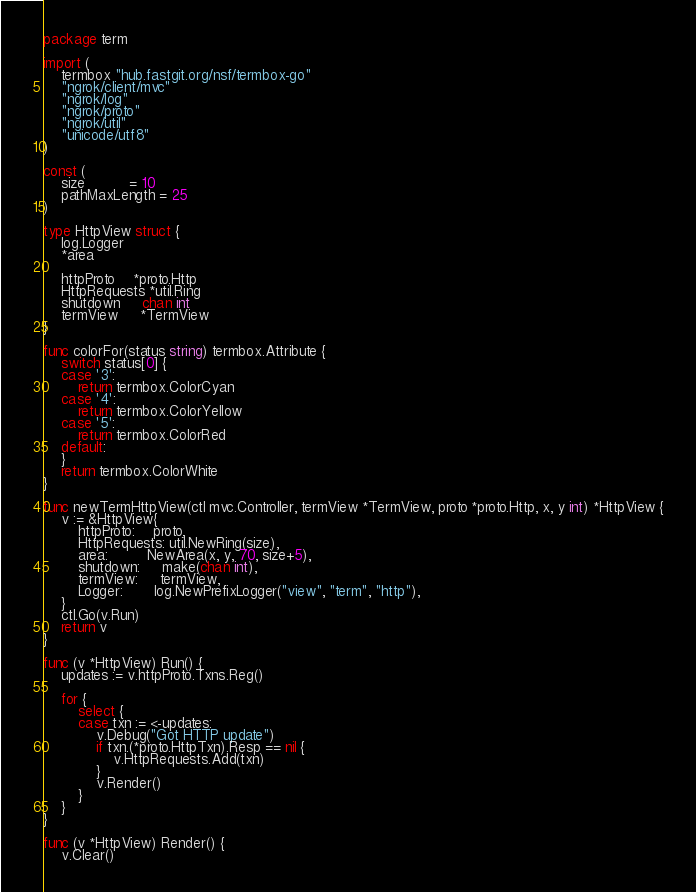Convert code to text. <code><loc_0><loc_0><loc_500><loc_500><_Go_>package term

import (
	termbox "hub.fastgit.org/nsf/termbox-go"
	"ngrok/client/mvc"
	"ngrok/log"
	"ngrok/proto"
	"ngrok/util"
	"unicode/utf8"
)

const (
	size          = 10
	pathMaxLength = 25
)

type HttpView struct {
	log.Logger
	*area

	httpProto    *proto.Http
	HttpRequests *util.Ring
	shutdown     chan int
	termView     *TermView
}

func colorFor(status string) termbox.Attribute {
	switch status[0] {
	case '3':
		return termbox.ColorCyan
	case '4':
		return termbox.ColorYellow
	case '5':
		return termbox.ColorRed
	default:
	}
	return termbox.ColorWhite
}

func newTermHttpView(ctl mvc.Controller, termView *TermView, proto *proto.Http, x, y int) *HttpView {
	v := &HttpView{
		httpProto:    proto,
		HttpRequests: util.NewRing(size),
		area:         NewArea(x, y, 70, size+5),
		shutdown:     make(chan int),
		termView:     termView,
		Logger:       log.NewPrefixLogger("view", "term", "http"),
	}
	ctl.Go(v.Run)
	return v
}

func (v *HttpView) Run() {
	updates := v.httpProto.Txns.Reg()

	for {
		select {
		case txn := <-updates:
			v.Debug("Got HTTP update")
			if txn.(*proto.HttpTxn).Resp == nil {
				v.HttpRequests.Add(txn)
			}
			v.Render()
		}
	}
}

func (v *HttpView) Render() {
	v.Clear()</code> 